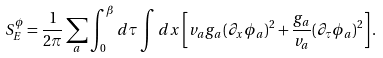Convert formula to latex. <formula><loc_0><loc_0><loc_500><loc_500>S ^ { \phi } _ { E } = \frac { 1 } { 2 \pi } \sum _ { a } \int _ { 0 } ^ { \beta } d \tau \int d x \left [ v _ { a } g _ { a } ( \partial _ { x } \phi _ { a } ) ^ { 2 } + \frac { g _ { a } } { v _ { a } } ( \partial _ { \tau } \phi _ { a } ) ^ { 2 } \right ] .</formula> 